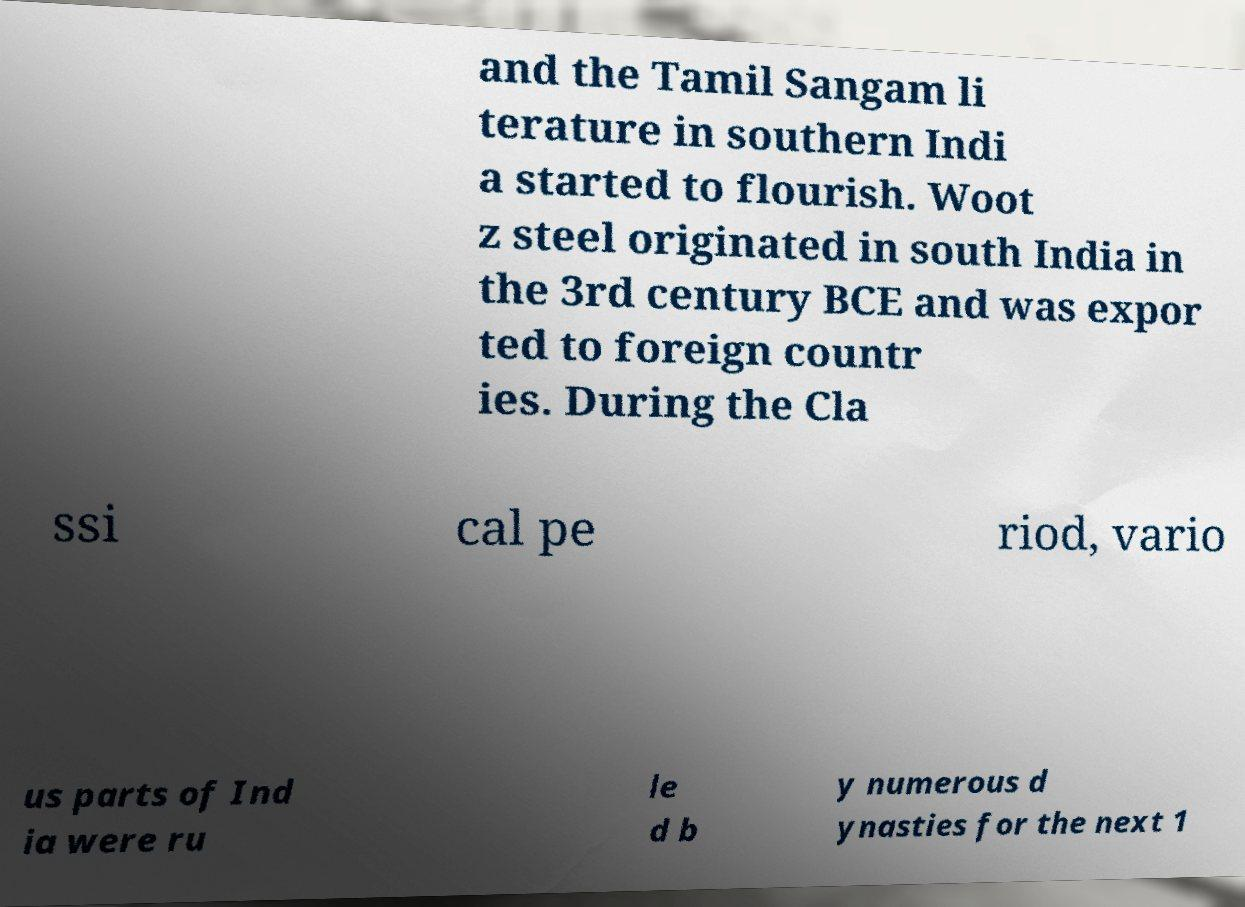Could you extract and type out the text from this image? and the Tamil Sangam li terature in southern Indi a started to flourish. Woot z steel originated in south India in the 3rd century BCE and was expor ted to foreign countr ies. During the Cla ssi cal pe riod, vario us parts of Ind ia were ru le d b y numerous d ynasties for the next 1 